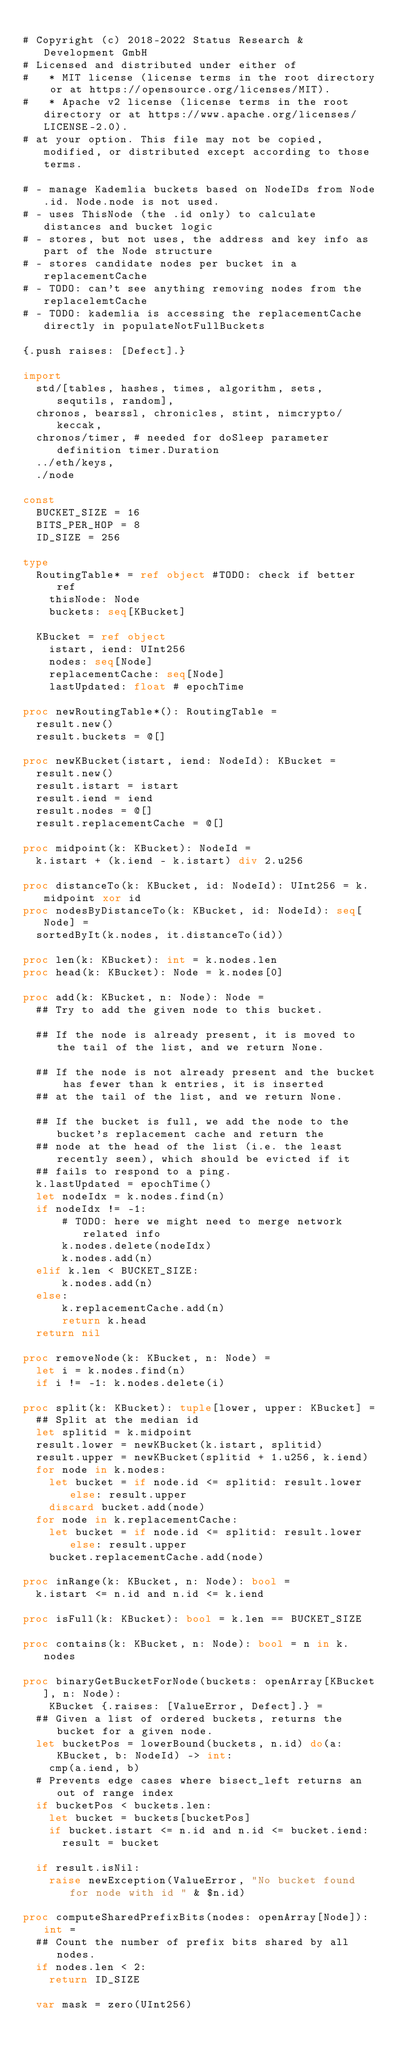Convert code to text. <code><loc_0><loc_0><loc_500><loc_500><_Nim_>
# Copyright (c) 2018-2022 Status Research & Development GmbH
# Licensed and distributed under either of
#   * MIT license (license terms in the root directory or at https://opensource.org/licenses/MIT).
#   * Apache v2 license (license terms in the root directory or at https://www.apache.org/licenses/LICENSE-2.0).
# at your option. This file may not be copied, modified, or distributed except according to those terms.

# - manage Kademlia buckets based on NodeIDs from Node.id. Node.node is not used.
# - uses ThisNode (the .id only) to calculate distances and bucket logic
# - stores, but not uses, the address and key info as part of the Node structure
# - stores candidate nodes per bucket in a replacementCache
# - TODO: can't see anything removing nodes from the replacelemtCache
# - TODO: kademlia is accessing the replacementCache directly in populateNotFullBuckets

{.push raises: [Defect].}

import
  std/[tables, hashes, times, algorithm, sets, sequtils, random],
  chronos, bearssl, chronicles, stint, nimcrypto/keccak,
  chronos/timer, # needed for doSleep parameter definition timer.Duration
  ../eth/keys,
  ./node

const
  BUCKET_SIZE = 16
  BITS_PER_HOP = 8
  ID_SIZE = 256

type
  RoutingTable* = ref object #TODO: check if better ref
    thisNode: Node
    buckets: seq[KBucket]

  KBucket = ref object
    istart, iend: UInt256
    nodes: seq[Node]
    replacementCache: seq[Node]
    lastUpdated: float # epochTime

proc newRoutingTable*(): RoutingTable =
  result.new()
  result.buckets = @[]

proc newKBucket(istart, iend: NodeId): KBucket =
  result.new()
  result.istart = istart
  result.iend = iend
  result.nodes = @[]
  result.replacementCache = @[]

proc midpoint(k: KBucket): NodeId =
  k.istart + (k.iend - k.istart) div 2.u256

proc distanceTo(k: KBucket, id: NodeId): UInt256 = k.midpoint xor id
proc nodesByDistanceTo(k: KBucket, id: NodeId): seq[Node] =
  sortedByIt(k.nodes, it.distanceTo(id))

proc len(k: KBucket): int = k.nodes.len
proc head(k: KBucket): Node = k.nodes[0]

proc add(k: KBucket, n: Node): Node =
  ## Try to add the given node to this bucket.

  ## If the node is already present, it is moved to the tail of the list, and we return None.

  ## If the node is not already present and the bucket has fewer than k entries, it is inserted
  ## at the tail of the list, and we return None.

  ## If the bucket is full, we add the node to the bucket's replacement cache and return the
  ## node at the head of the list (i.e. the least recently seen), which should be evicted if it
  ## fails to respond to a ping.
  k.lastUpdated = epochTime()
  let nodeIdx = k.nodes.find(n)
  if nodeIdx != -1:
      # TODO: here we might need to merge network related info
      k.nodes.delete(nodeIdx)
      k.nodes.add(n)
  elif k.len < BUCKET_SIZE:
      k.nodes.add(n)
  else:
      k.replacementCache.add(n)
      return k.head
  return nil

proc removeNode(k: KBucket, n: Node) =
  let i = k.nodes.find(n)
  if i != -1: k.nodes.delete(i)

proc split(k: KBucket): tuple[lower, upper: KBucket] =
  ## Split at the median id
  let splitid = k.midpoint
  result.lower = newKBucket(k.istart, splitid)
  result.upper = newKBucket(splitid + 1.u256, k.iend)
  for node in k.nodes:
    let bucket = if node.id <= splitid: result.lower else: result.upper
    discard bucket.add(node)
  for node in k.replacementCache:
    let bucket = if node.id <= splitid: result.lower else: result.upper
    bucket.replacementCache.add(node)

proc inRange(k: KBucket, n: Node): bool =
  k.istart <= n.id and n.id <= k.iend

proc isFull(k: KBucket): bool = k.len == BUCKET_SIZE

proc contains(k: KBucket, n: Node): bool = n in k.nodes

proc binaryGetBucketForNode(buckets: openArray[KBucket], n: Node):
    KBucket {.raises: [ValueError, Defect].} =
  ## Given a list of ordered buckets, returns the bucket for a given node.
  let bucketPos = lowerBound(buckets, n.id) do(a: KBucket, b: NodeId) -> int:
    cmp(a.iend, b)
  # Prevents edge cases where bisect_left returns an out of range index
  if bucketPos < buckets.len:
    let bucket = buckets[bucketPos]
    if bucket.istart <= n.id and n.id <= bucket.iend:
      result = bucket

  if result.isNil:
    raise newException(ValueError, "No bucket found for node with id " & $n.id)

proc computeSharedPrefixBits(nodes: openArray[Node]): int =
  ## Count the number of prefix bits shared by all nodes.
  if nodes.len < 2:
    return ID_SIZE

  var mask = zero(UInt256)</code> 